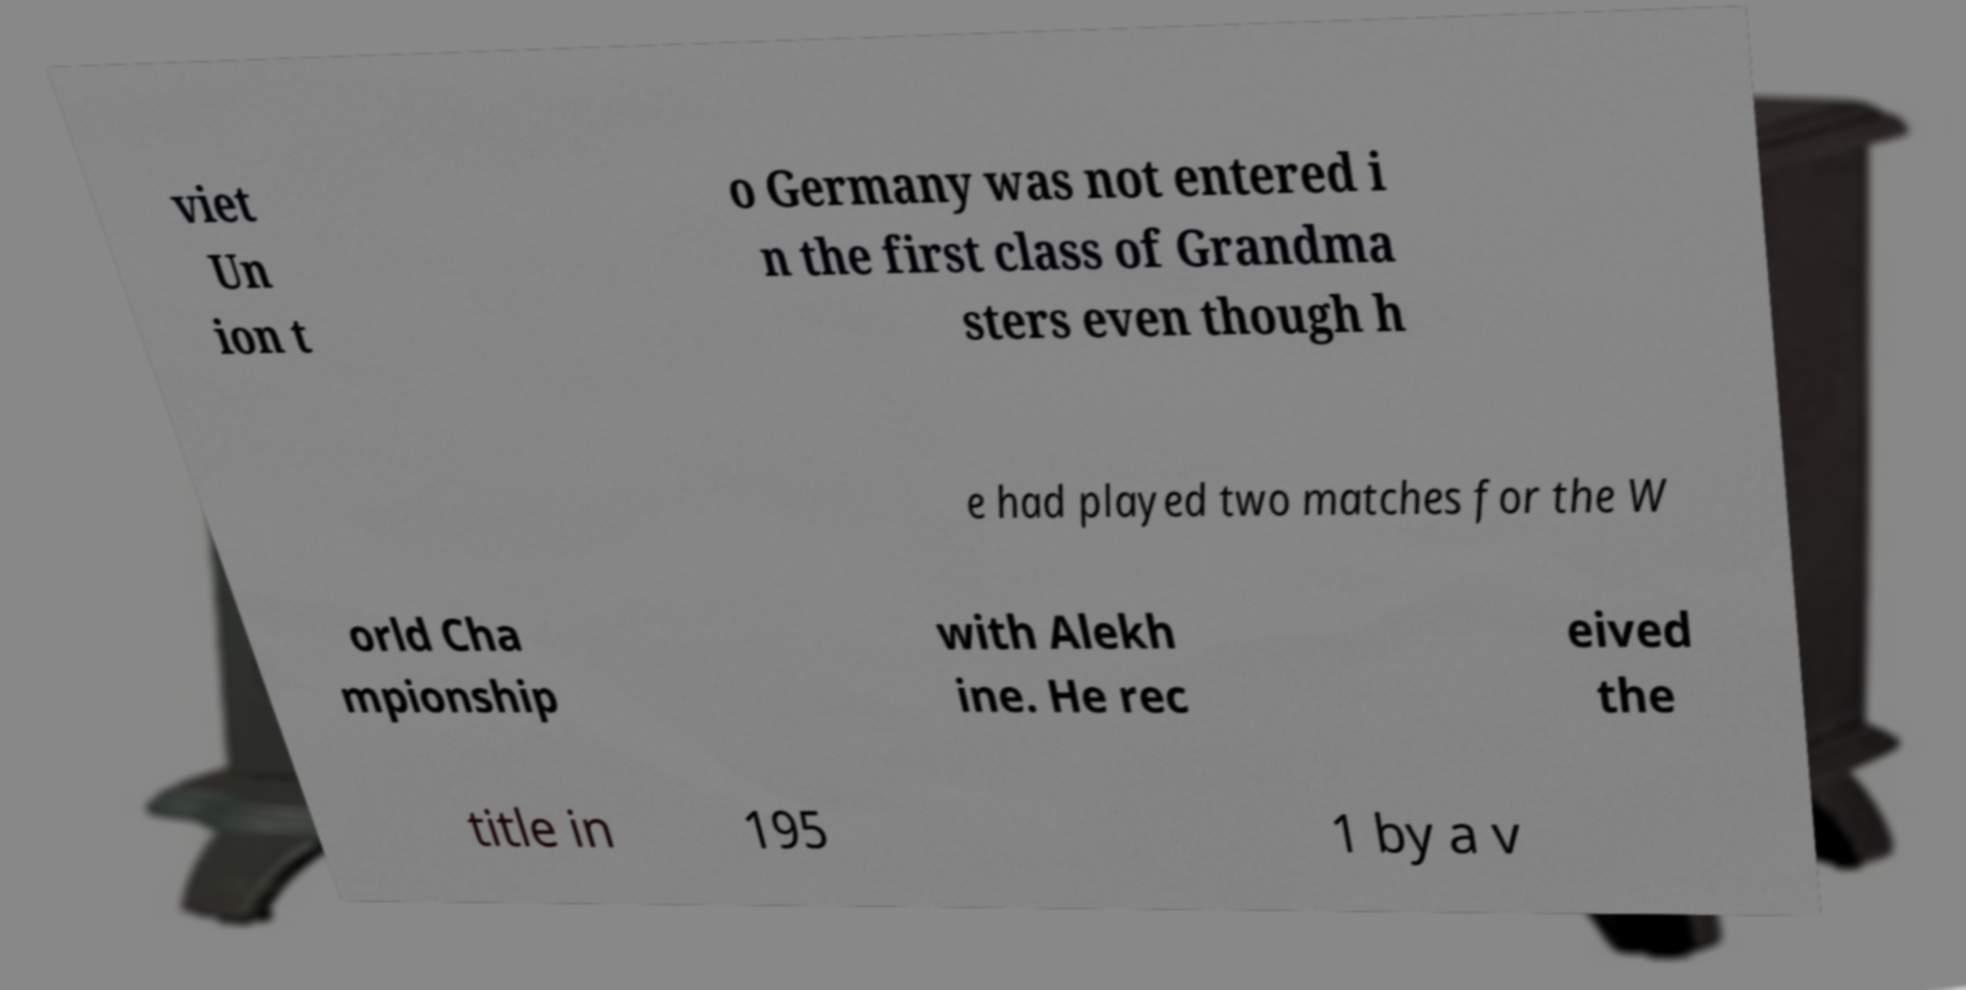Can you accurately transcribe the text from the provided image for me? viet Un ion t o Germany was not entered i n the first class of Grandma sters even though h e had played two matches for the W orld Cha mpionship with Alekh ine. He rec eived the title in 195 1 by a v 